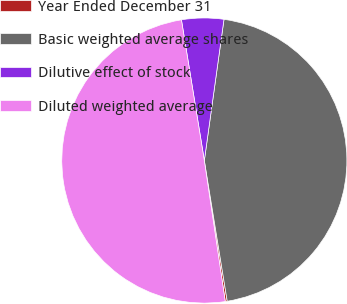Convert chart. <chart><loc_0><loc_0><loc_500><loc_500><pie_chart><fcel>Year Ended December 31<fcel>Basic weighted average shares<fcel>Dilutive effect of stock<fcel>Diluted weighted average<nl><fcel>0.22%<fcel>45.23%<fcel>4.77%<fcel>49.78%<nl></chart> 